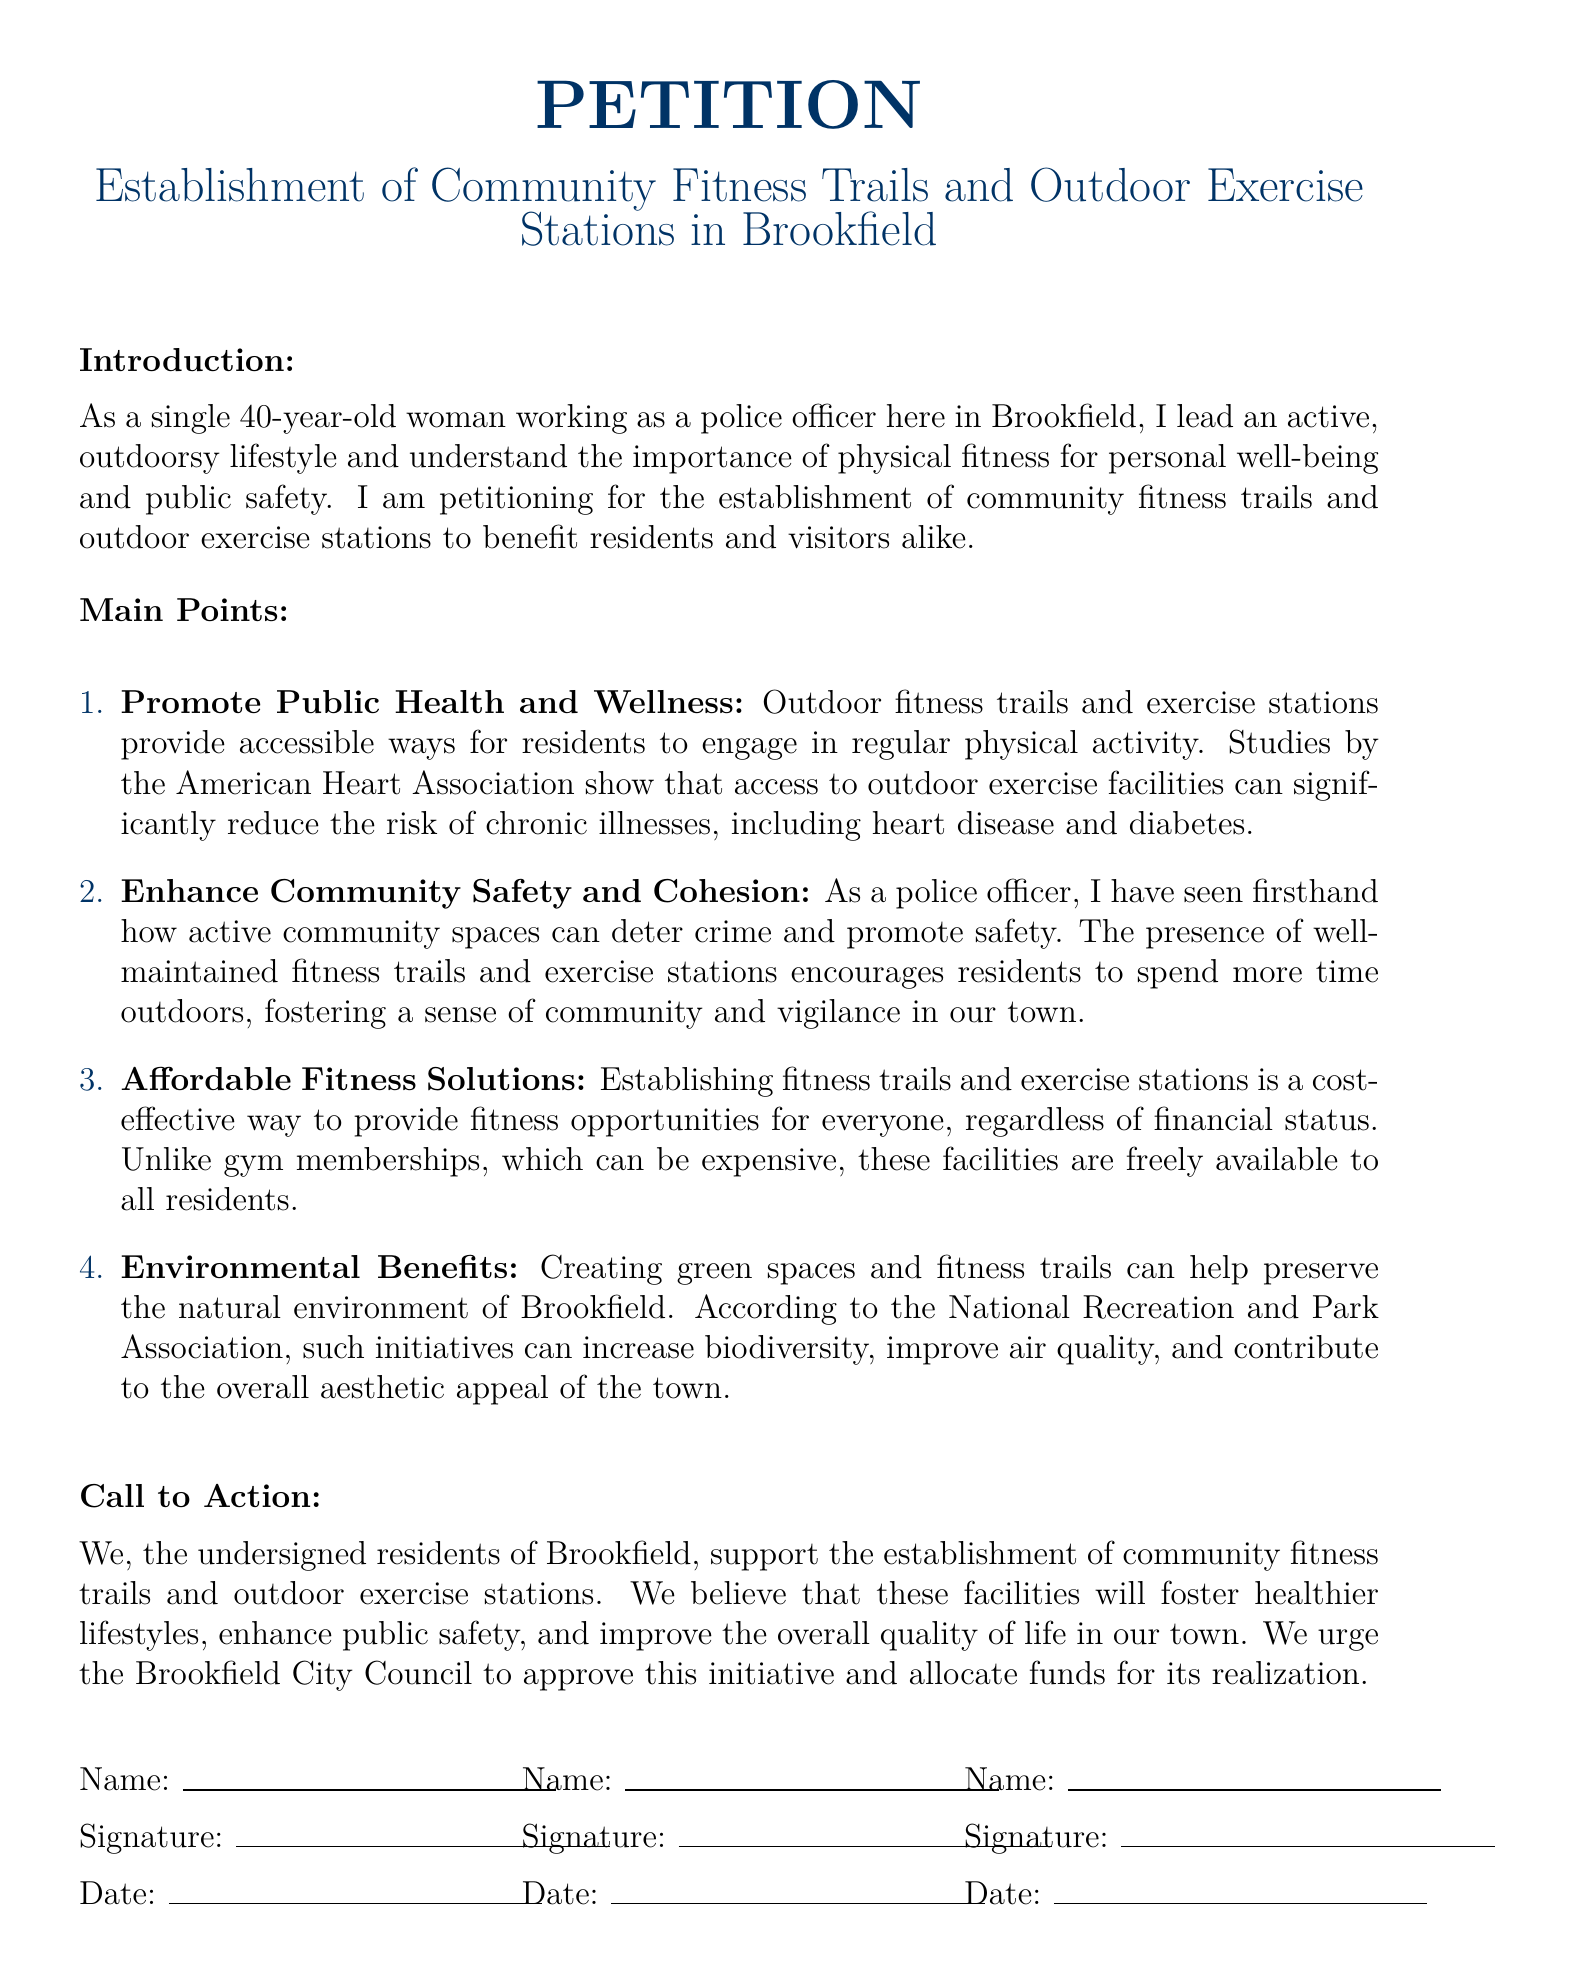What is the title of the petition? The title of the petition is explicitly stated in the document header.
Answer: Establishment of Community Fitness Trails and Outdoor Exercise Stations in Brookfield Who is the petition directed to? The petition's call to action suggests it is aimed at the local governing body.
Answer: Brookfield City Council What is the first main point mentioned in the petition? The main points of the petition are numbered; the first one is focused on health.
Answer: Promote Public Health and Wellness What are the proposed facilities mentioned in the petition? The document outlines specific types of facilities that are proposed for the community.
Answer: Community fitness trails and outdoor exercise stations According to the document, what organization conducted a study referenced in the petition? A specific organization is cited regarding the benefits of outdoor facilities in the petition.
Answer: American Heart Association How many main points are listed in the petition? The number of main points is indicated by the enumerated list in the document.
Answer: Four What environmental benefit is mentioned in the petition? The petition discusses environmental benefits related to establishing fitness trails.
Answer: Preserve the natural environment What is the document type being described? The specific type of document that presents a request to authorities is mentioned in the title.
Answer: Petition 